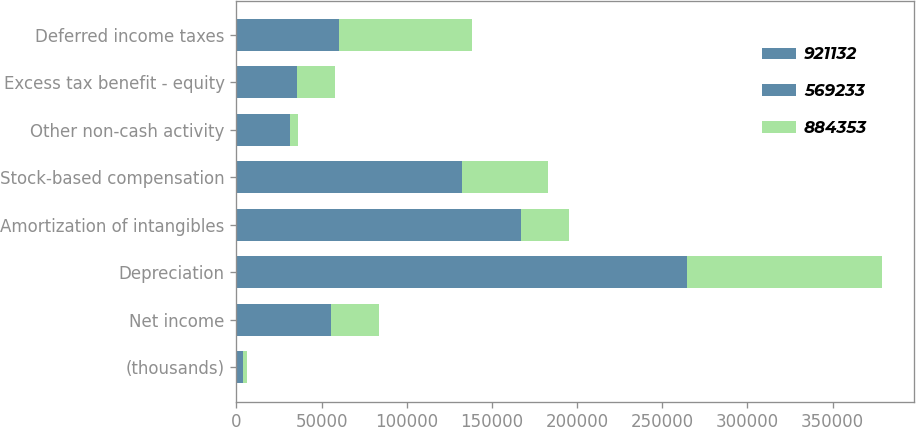Convert chart to OTSL. <chart><loc_0><loc_0><loc_500><loc_500><stacked_bar_chart><ecel><fcel>(thousands)<fcel>Net income<fcel>Depreciation<fcel>Amortization of intangibles<fcel>Stock-based compensation<fcel>Other non-cash activity<fcel>Excess tax benefit - equity<fcel>Deferred income taxes<nl><fcel>921132<fcel>2016<fcel>27906<fcel>134540<fcel>75250<fcel>63421<fcel>24570<fcel>10453<fcel>8124<nl><fcel>569233<fcel>2015<fcel>27906<fcel>130147<fcel>92093<fcel>68919<fcel>6974<fcel>25045<fcel>52214<nl><fcel>884353<fcel>2014<fcel>27906<fcel>114064<fcel>27906<fcel>50812<fcel>4423<fcel>22231<fcel>77711<nl></chart> 